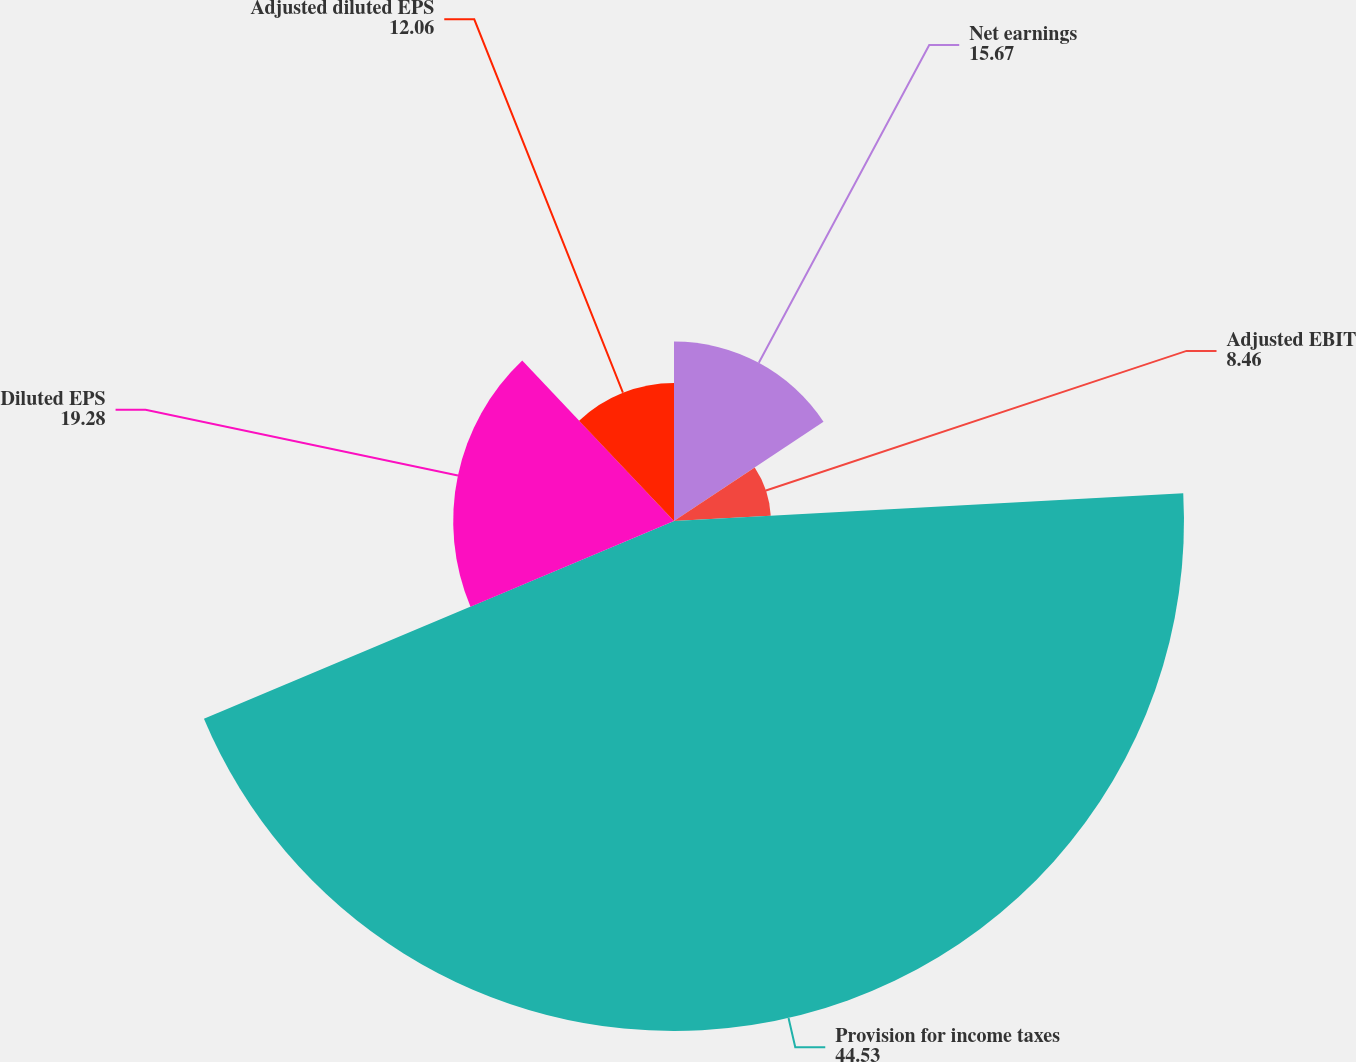Convert chart to OTSL. <chart><loc_0><loc_0><loc_500><loc_500><pie_chart><fcel>Net earnings<fcel>Adjusted EBIT<fcel>Provision for income taxes<fcel>Diluted EPS<fcel>Adjusted diluted EPS<nl><fcel>15.67%<fcel>8.46%<fcel>44.53%<fcel>19.28%<fcel>12.06%<nl></chart> 